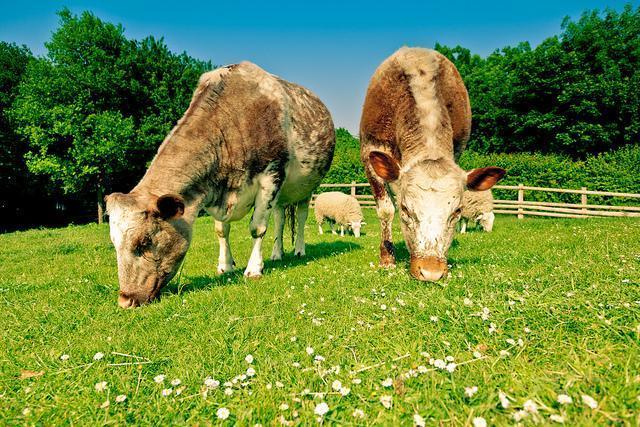How many cows can be seen?
Give a very brief answer. 2. 